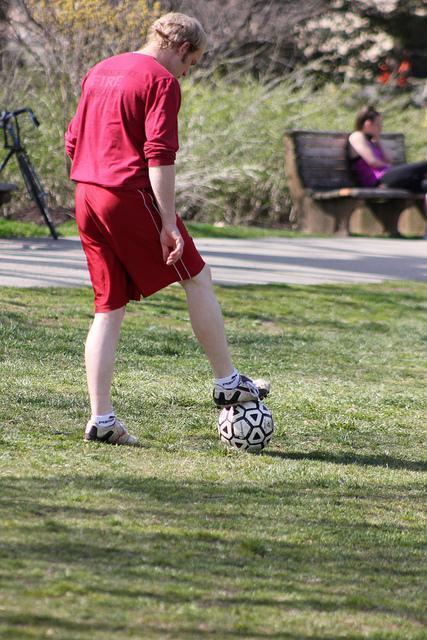How many people are sitting on the bench?
Give a very brief answer. 1. How many people are visible?
Give a very brief answer. 2. 